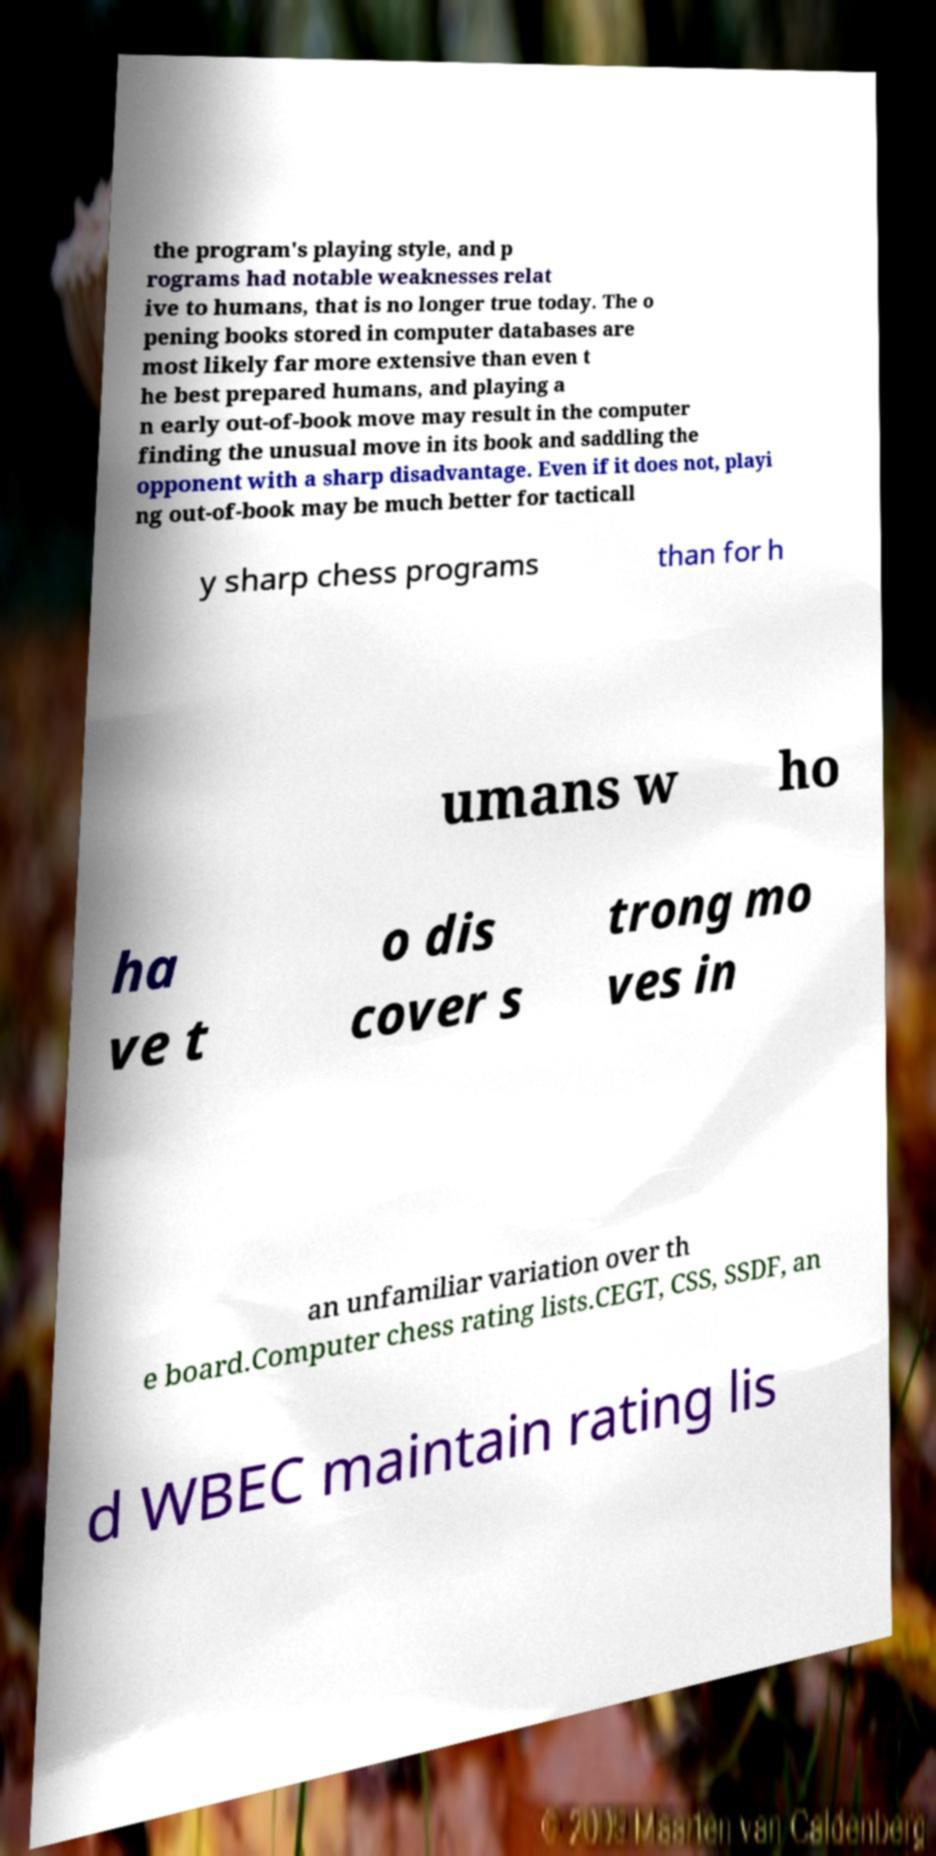Could you extract and type out the text from this image? the program's playing style, and p rograms had notable weaknesses relat ive to humans, that is no longer true today. The o pening books stored in computer databases are most likely far more extensive than even t he best prepared humans, and playing a n early out-of-book move may result in the computer finding the unusual move in its book and saddling the opponent with a sharp disadvantage. Even if it does not, playi ng out-of-book may be much better for tacticall y sharp chess programs than for h umans w ho ha ve t o dis cover s trong mo ves in an unfamiliar variation over th e board.Computer chess rating lists.CEGT, CSS, SSDF, an d WBEC maintain rating lis 